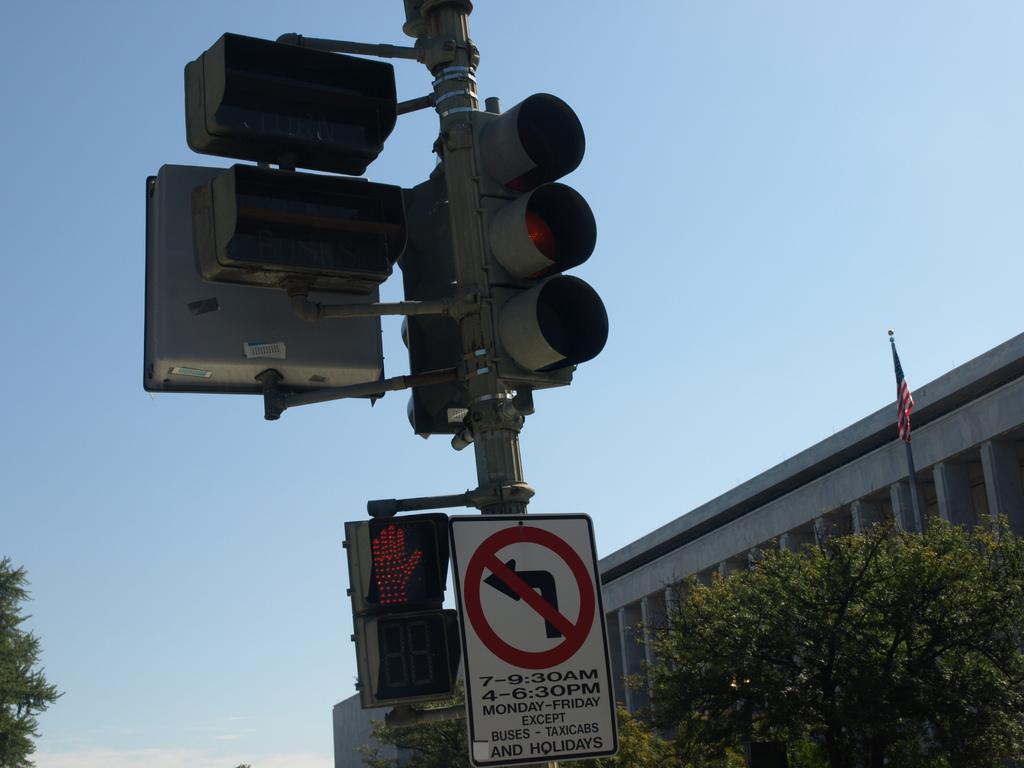How would you summarize this image in a sentence or two? In this picture we can observe signals fixed to the pole. We can observe a board which is in white color. In the background there are trees and a building. We can observe a flag on the right side. In the background there is a sky. 